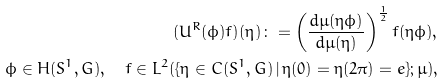<formula> <loc_0><loc_0><loc_500><loc_500>( U ^ { R } ( \phi ) f ) ( \eta ) \colon = \left ( \frac { d \mu ( \eta \phi ) } { d \mu ( \eta ) } \right ) ^ { \frac { 1 } { 2 } } f ( \eta \phi ) , \\ \phi \in H ( S ^ { 1 } , G ) , \quad f \in L ^ { 2 } ( \{ \eta \in C ( S ^ { 1 } , G ) \, | \, \eta ( 0 ) = \eta ( 2 \pi ) = e \} ; \mu ) ,</formula> 